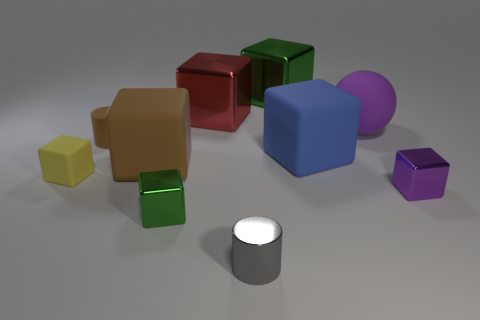How many objects in total can be seen, and what is the lighting like? There are a total of seven objects visible in the image. The lighting is soft and diffuse, with a slight highlight on the surfaces facing upwards, suggesting a calm and evenly lit indoor setting. 